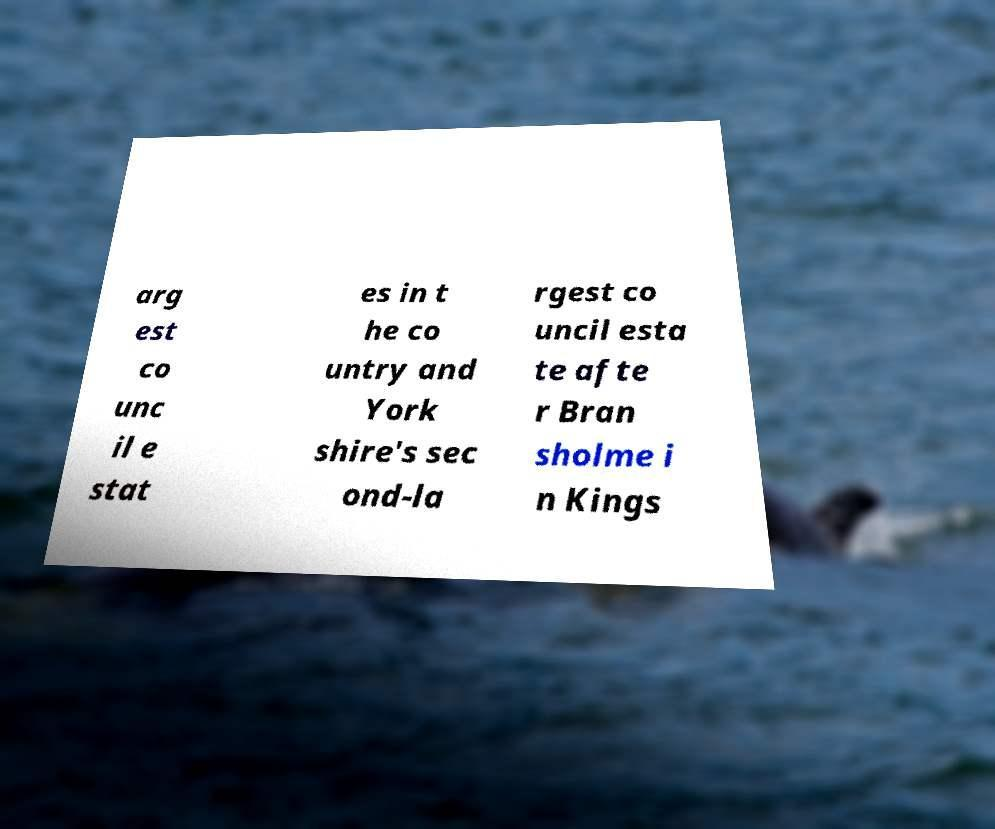There's text embedded in this image that I need extracted. Can you transcribe it verbatim? arg est co unc il e stat es in t he co untry and York shire's sec ond-la rgest co uncil esta te afte r Bran sholme i n Kings 